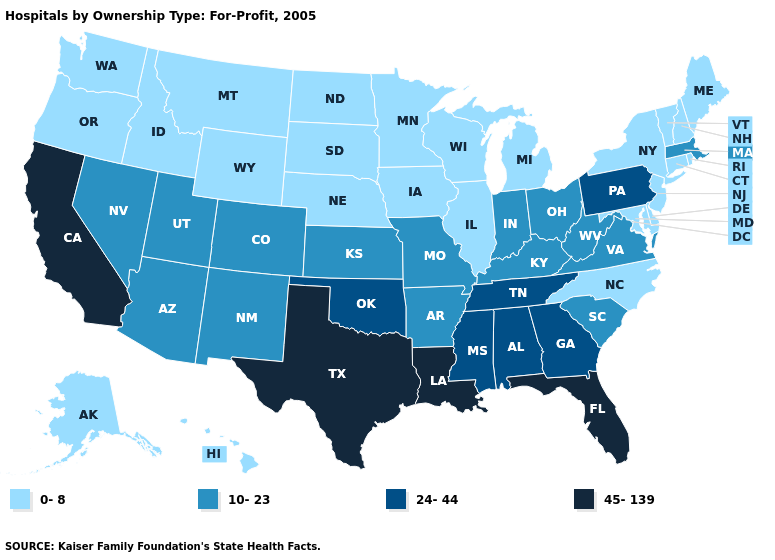Does Illinois have a lower value than Wyoming?
Write a very short answer. No. What is the value of Wyoming?
Write a very short answer. 0-8. Does New Mexico have the highest value in the West?
Short answer required. No. What is the highest value in the West ?
Write a very short answer. 45-139. Name the states that have a value in the range 10-23?
Give a very brief answer. Arizona, Arkansas, Colorado, Indiana, Kansas, Kentucky, Massachusetts, Missouri, Nevada, New Mexico, Ohio, South Carolina, Utah, Virginia, West Virginia. Name the states that have a value in the range 10-23?
Answer briefly. Arizona, Arkansas, Colorado, Indiana, Kansas, Kentucky, Massachusetts, Missouri, Nevada, New Mexico, Ohio, South Carolina, Utah, Virginia, West Virginia. Among the states that border Oregon , does Idaho have the lowest value?
Quick response, please. Yes. Among the states that border Massachusetts , which have the highest value?
Write a very short answer. Connecticut, New Hampshire, New York, Rhode Island, Vermont. Name the states that have a value in the range 24-44?
Short answer required. Alabama, Georgia, Mississippi, Oklahoma, Pennsylvania, Tennessee. What is the highest value in the West ?
Keep it brief. 45-139. What is the value of Oklahoma?
Answer briefly. 24-44. What is the highest value in states that border Texas?
Concise answer only. 45-139. What is the highest value in the USA?
Give a very brief answer. 45-139. Does the first symbol in the legend represent the smallest category?
Write a very short answer. Yes. Name the states that have a value in the range 10-23?
Quick response, please. Arizona, Arkansas, Colorado, Indiana, Kansas, Kentucky, Massachusetts, Missouri, Nevada, New Mexico, Ohio, South Carolina, Utah, Virginia, West Virginia. 